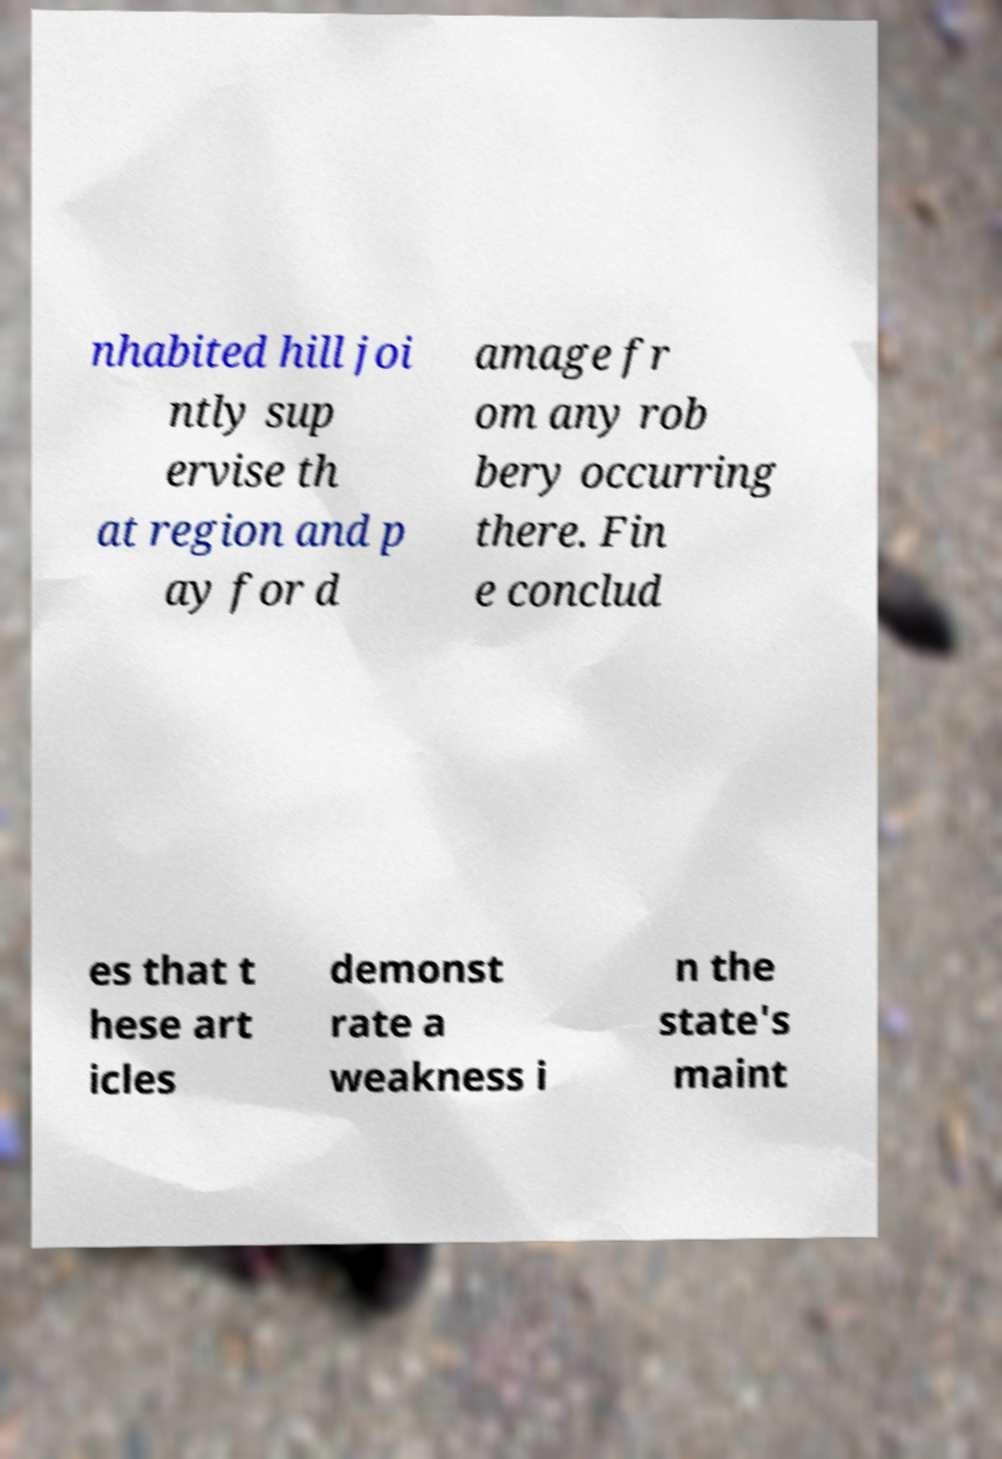Please read and relay the text visible in this image. What does it say? nhabited hill joi ntly sup ervise th at region and p ay for d amage fr om any rob bery occurring there. Fin e conclud es that t hese art icles demonst rate a weakness i n the state's maint 